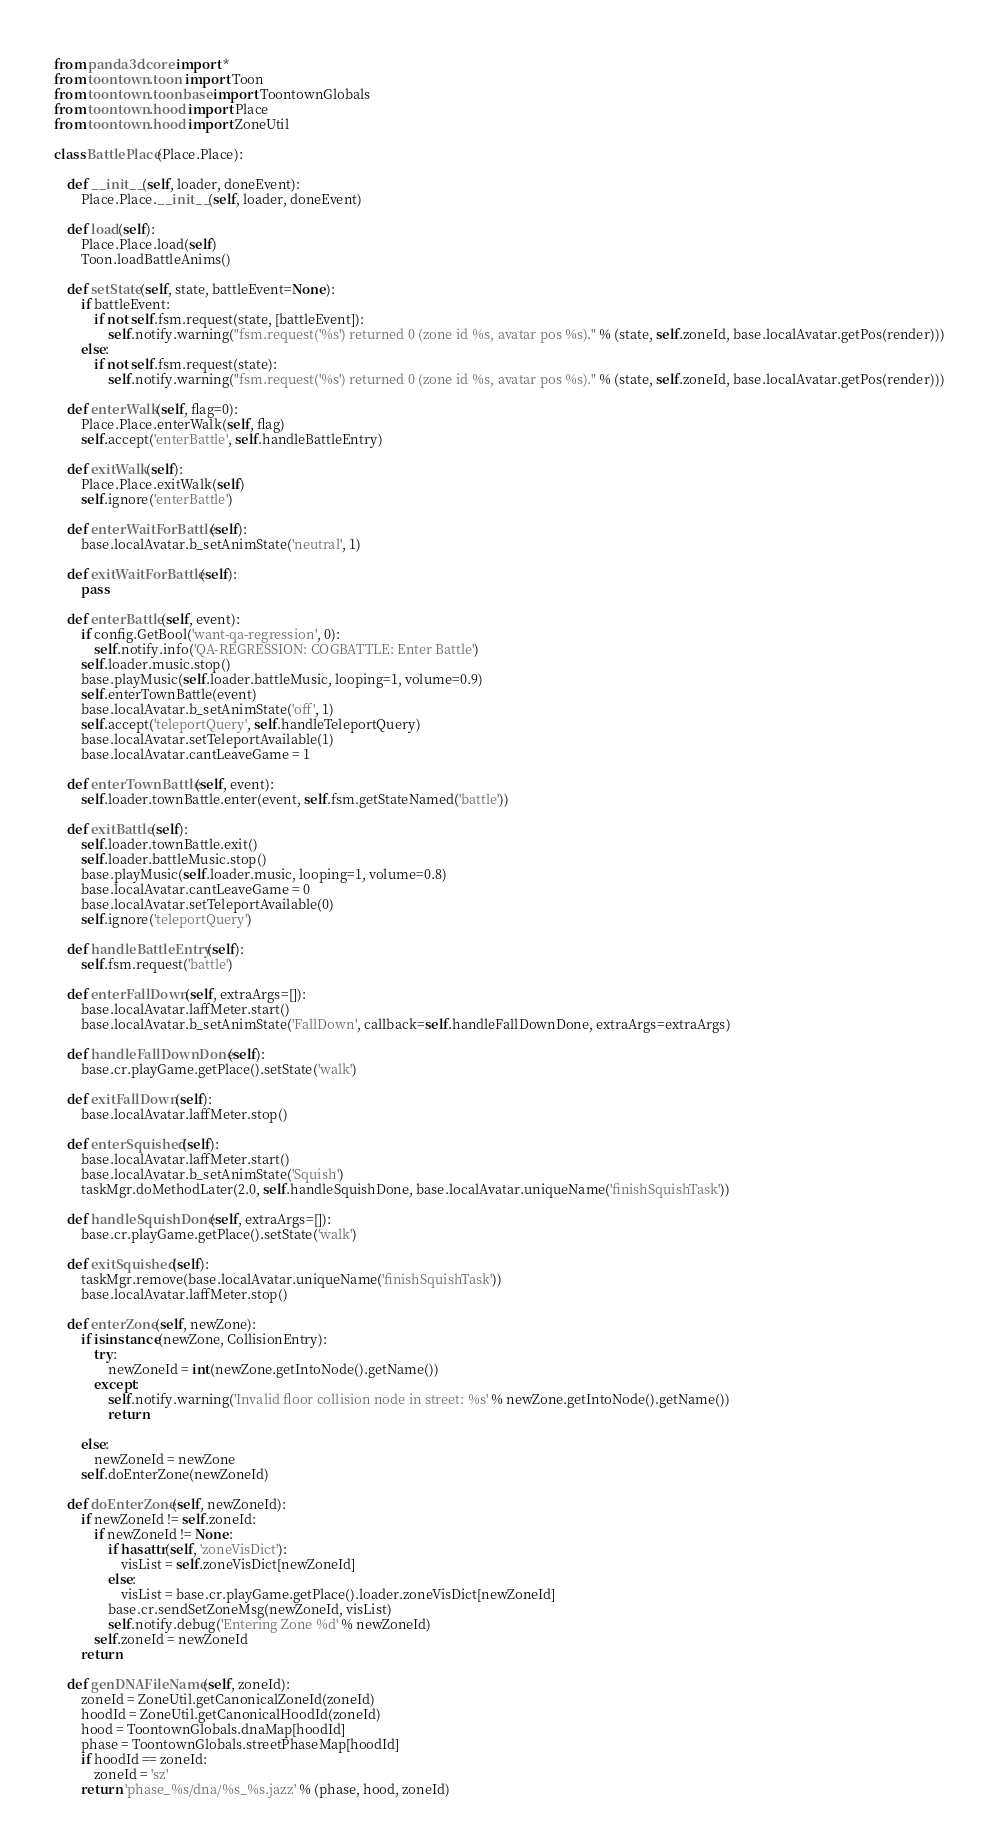Convert code to text. <code><loc_0><loc_0><loc_500><loc_500><_Python_>from panda3d.core import *
from toontown.toon import Toon
from toontown.toonbase import ToontownGlobals
from toontown.hood import Place
from toontown.hood import ZoneUtil

class BattlePlace(Place.Place):

    def __init__(self, loader, doneEvent):
        Place.Place.__init__(self, loader, doneEvent)

    def load(self):
        Place.Place.load(self)
        Toon.loadBattleAnims()

    def setState(self, state, battleEvent=None):
        if battleEvent:
            if not self.fsm.request(state, [battleEvent]):
                self.notify.warning("fsm.request('%s') returned 0 (zone id %s, avatar pos %s)." % (state, self.zoneId, base.localAvatar.getPos(render)))
        else:
            if not self.fsm.request(state):
                self.notify.warning("fsm.request('%s') returned 0 (zone id %s, avatar pos %s)." % (state, self.zoneId, base.localAvatar.getPos(render)))

    def enterWalk(self, flag=0):
        Place.Place.enterWalk(self, flag)
        self.accept('enterBattle', self.handleBattleEntry)

    def exitWalk(self):
        Place.Place.exitWalk(self)
        self.ignore('enterBattle')

    def enterWaitForBattle(self):
        base.localAvatar.b_setAnimState('neutral', 1)

    def exitWaitForBattle(self):
        pass

    def enterBattle(self, event):
        if config.GetBool('want-qa-regression', 0):
            self.notify.info('QA-REGRESSION: COGBATTLE: Enter Battle')
        self.loader.music.stop()
        base.playMusic(self.loader.battleMusic, looping=1, volume=0.9)
        self.enterTownBattle(event)
        base.localAvatar.b_setAnimState('off', 1)
        self.accept('teleportQuery', self.handleTeleportQuery)
        base.localAvatar.setTeleportAvailable(1)
        base.localAvatar.cantLeaveGame = 1

    def enterTownBattle(self, event):
        self.loader.townBattle.enter(event, self.fsm.getStateNamed('battle'))

    def exitBattle(self):
        self.loader.townBattle.exit()
        self.loader.battleMusic.stop()
        base.playMusic(self.loader.music, looping=1, volume=0.8)
        base.localAvatar.cantLeaveGame = 0
        base.localAvatar.setTeleportAvailable(0)
        self.ignore('teleportQuery')

    def handleBattleEntry(self):
        self.fsm.request('battle')

    def enterFallDown(self, extraArgs=[]):
        base.localAvatar.laffMeter.start()
        base.localAvatar.b_setAnimState('FallDown', callback=self.handleFallDownDone, extraArgs=extraArgs)

    def handleFallDownDone(self):
        base.cr.playGame.getPlace().setState('walk')

    def exitFallDown(self):
        base.localAvatar.laffMeter.stop()

    def enterSquished(self):
        base.localAvatar.laffMeter.start()
        base.localAvatar.b_setAnimState('Squish')
        taskMgr.doMethodLater(2.0, self.handleSquishDone, base.localAvatar.uniqueName('finishSquishTask'))

    def handleSquishDone(self, extraArgs=[]):
        base.cr.playGame.getPlace().setState('walk')

    def exitSquished(self):
        taskMgr.remove(base.localAvatar.uniqueName('finishSquishTask'))
        base.localAvatar.laffMeter.stop()

    def enterZone(self, newZone):
        if isinstance(newZone, CollisionEntry):
            try:
                newZoneId = int(newZone.getIntoNode().getName())
            except:
                self.notify.warning('Invalid floor collision node in street: %s' % newZone.getIntoNode().getName())
                return

        else:
            newZoneId = newZone
        self.doEnterZone(newZoneId)

    def doEnterZone(self, newZoneId):
        if newZoneId != self.zoneId:
            if newZoneId != None:
                if hasattr(self, 'zoneVisDict'):
                    visList = self.zoneVisDict[newZoneId]
                else:
                    visList = base.cr.playGame.getPlace().loader.zoneVisDict[newZoneId]
                base.cr.sendSetZoneMsg(newZoneId, visList)
                self.notify.debug('Entering Zone %d' % newZoneId)
            self.zoneId = newZoneId
        return

    def genDNAFileName(self, zoneId):
        zoneId = ZoneUtil.getCanonicalZoneId(zoneId)
        hoodId = ZoneUtil.getCanonicalHoodId(zoneId)
        hood = ToontownGlobals.dnaMap[hoodId]
        phase = ToontownGlobals.streetPhaseMap[hoodId]
        if hoodId == zoneId:
            zoneId = 'sz'
        return 'phase_%s/dna/%s_%s.jazz' % (phase, hood, zoneId)</code> 